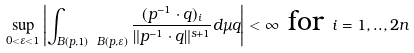Convert formula to latex. <formula><loc_0><loc_0><loc_500><loc_500>\sup _ { 0 < \varepsilon < 1 } \left | \int _ { B ( p , 1 ) \ B ( p , \varepsilon ) } \frac { ( p ^ { - 1 } \cdot q ) _ { i } } { \| p ^ { - 1 } \cdot q \| ^ { s + 1 } } d \mu q \right | < \infty \text { for } i = 1 , . . , 2 n</formula> 